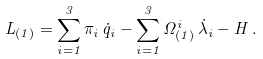Convert formula to latex. <formula><loc_0><loc_0><loc_500><loc_500>L _ { ( 1 ) } = \sum _ { i = 1 } ^ { 3 } \pi _ { i } \, \dot { q } _ { i } - \sum _ { i = 1 } ^ { 3 } \Omega _ { ( 1 ) } ^ { i } \, \dot { \lambda } _ { i } - H \, .</formula> 